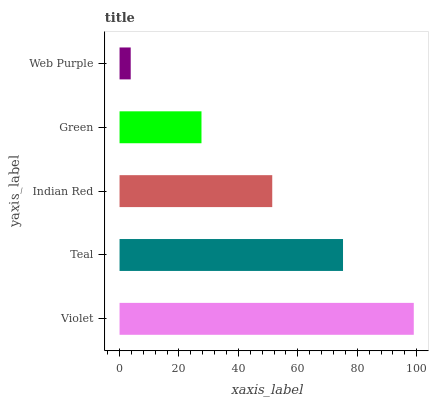Is Web Purple the minimum?
Answer yes or no. Yes. Is Violet the maximum?
Answer yes or no. Yes. Is Teal the minimum?
Answer yes or no. No. Is Teal the maximum?
Answer yes or no. No. Is Violet greater than Teal?
Answer yes or no. Yes. Is Teal less than Violet?
Answer yes or no. Yes. Is Teal greater than Violet?
Answer yes or no. No. Is Violet less than Teal?
Answer yes or no. No. Is Indian Red the high median?
Answer yes or no. Yes. Is Indian Red the low median?
Answer yes or no. Yes. Is Green the high median?
Answer yes or no. No. Is Web Purple the low median?
Answer yes or no. No. 